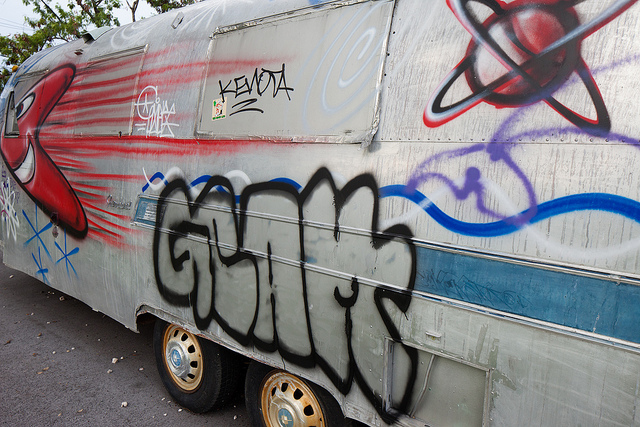Please transcribe the text in this image. KENOTA 